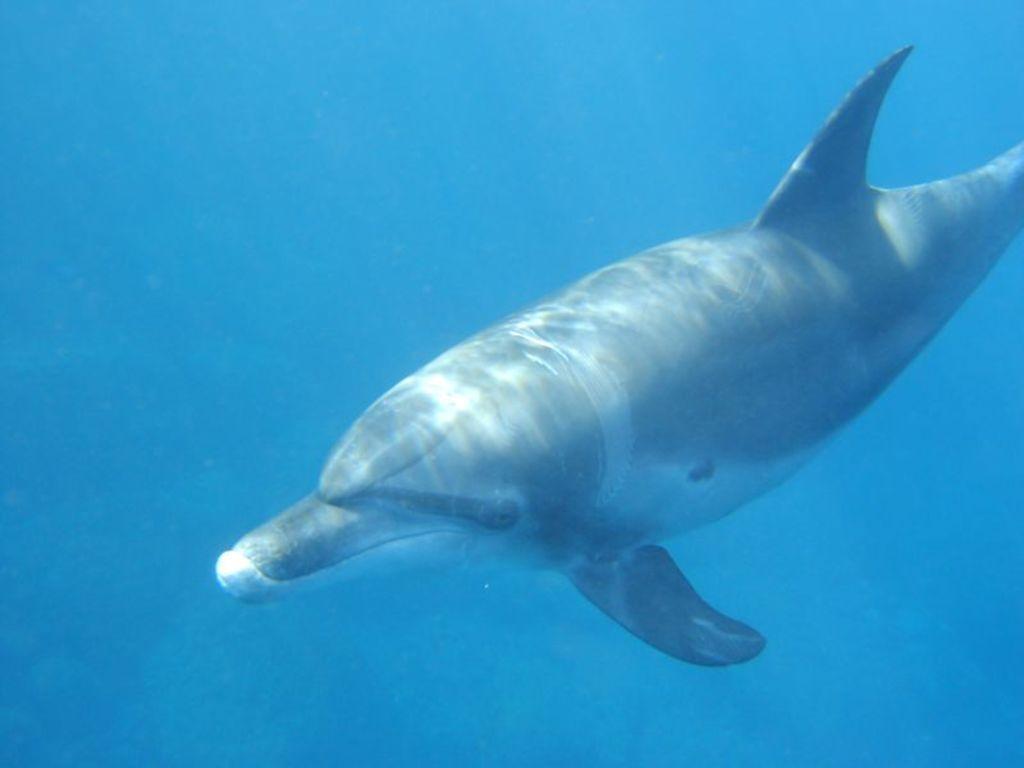Please provide a concise description of this image. In this image, I can see a dolphin in the water. This water looks blue in color. 